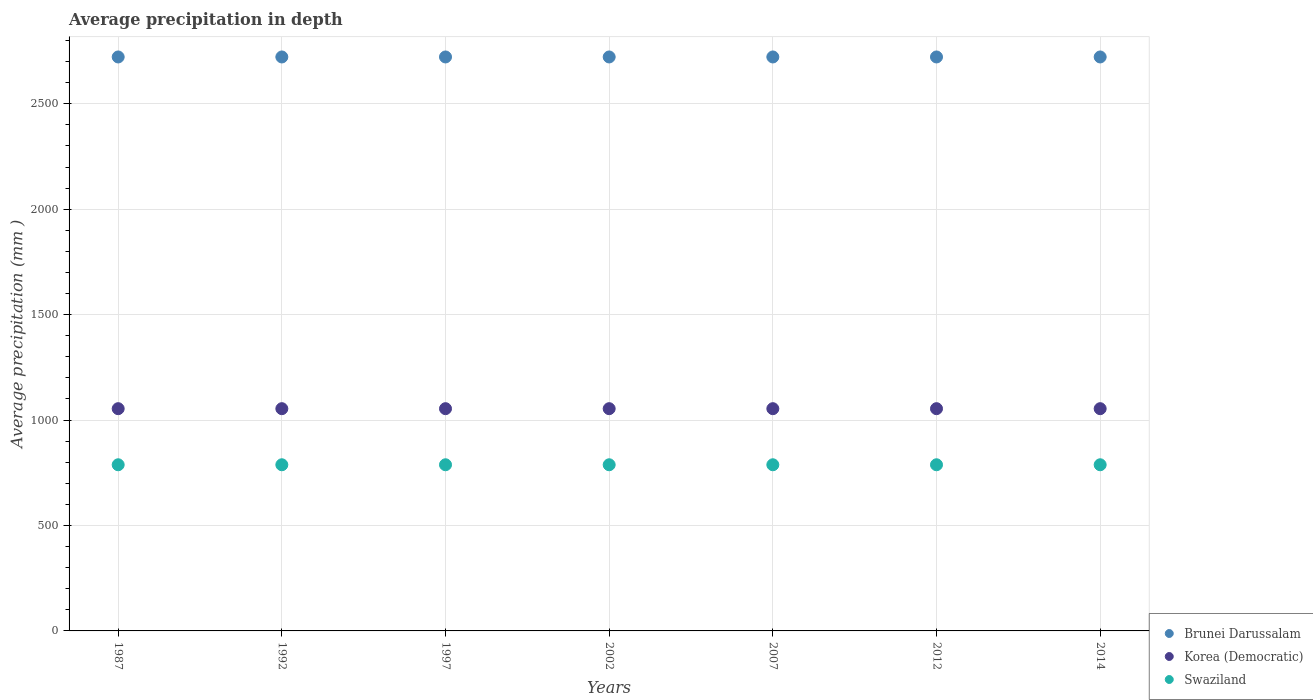Is the number of dotlines equal to the number of legend labels?
Your answer should be compact. Yes. What is the average precipitation in Korea (Democratic) in 1997?
Ensure brevity in your answer.  1054. Across all years, what is the maximum average precipitation in Korea (Democratic)?
Ensure brevity in your answer.  1054. Across all years, what is the minimum average precipitation in Korea (Democratic)?
Your answer should be very brief. 1054. In which year was the average precipitation in Brunei Darussalam minimum?
Your answer should be very brief. 1987. What is the total average precipitation in Swaziland in the graph?
Give a very brief answer. 5516. What is the difference between the average precipitation in Korea (Democratic) in 1992 and the average precipitation in Swaziland in 2014?
Your answer should be compact. 266. What is the average average precipitation in Brunei Darussalam per year?
Provide a succinct answer. 2722. In the year 2014, what is the difference between the average precipitation in Korea (Democratic) and average precipitation in Swaziland?
Offer a very short reply. 266. Is the average precipitation in Korea (Democratic) in 1992 less than that in 1997?
Offer a very short reply. No. In how many years, is the average precipitation in Brunei Darussalam greater than the average average precipitation in Brunei Darussalam taken over all years?
Provide a succinct answer. 0. Does the average precipitation in Swaziland monotonically increase over the years?
Provide a short and direct response. No. Are the values on the major ticks of Y-axis written in scientific E-notation?
Give a very brief answer. No. Does the graph contain any zero values?
Ensure brevity in your answer.  No. Does the graph contain grids?
Give a very brief answer. Yes. How are the legend labels stacked?
Your response must be concise. Vertical. What is the title of the graph?
Keep it short and to the point. Average precipitation in depth. Does "Malta" appear as one of the legend labels in the graph?
Your answer should be compact. No. What is the label or title of the Y-axis?
Your response must be concise. Average precipitation (mm ). What is the Average precipitation (mm ) of Brunei Darussalam in 1987?
Offer a very short reply. 2722. What is the Average precipitation (mm ) of Korea (Democratic) in 1987?
Your answer should be very brief. 1054. What is the Average precipitation (mm ) of Swaziland in 1987?
Make the answer very short. 788. What is the Average precipitation (mm ) of Brunei Darussalam in 1992?
Ensure brevity in your answer.  2722. What is the Average precipitation (mm ) in Korea (Democratic) in 1992?
Your answer should be very brief. 1054. What is the Average precipitation (mm ) in Swaziland in 1992?
Offer a very short reply. 788. What is the Average precipitation (mm ) of Brunei Darussalam in 1997?
Your answer should be compact. 2722. What is the Average precipitation (mm ) of Korea (Democratic) in 1997?
Your answer should be compact. 1054. What is the Average precipitation (mm ) in Swaziland in 1997?
Keep it short and to the point. 788. What is the Average precipitation (mm ) in Brunei Darussalam in 2002?
Give a very brief answer. 2722. What is the Average precipitation (mm ) of Korea (Democratic) in 2002?
Your response must be concise. 1054. What is the Average precipitation (mm ) of Swaziland in 2002?
Keep it short and to the point. 788. What is the Average precipitation (mm ) in Brunei Darussalam in 2007?
Keep it short and to the point. 2722. What is the Average precipitation (mm ) in Korea (Democratic) in 2007?
Ensure brevity in your answer.  1054. What is the Average precipitation (mm ) of Swaziland in 2007?
Offer a terse response. 788. What is the Average precipitation (mm ) of Brunei Darussalam in 2012?
Offer a terse response. 2722. What is the Average precipitation (mm ) in Korea (Democratic) in 2012?
Give a very brief answer. 1054. What is the Average precipitation (mm ) in Swaziland in 2012?
Your answer should be compact. 788. What is the Average precipitation (mm ) in Brunei Darussalam in 2014?
Ensure brevity in your answer.  2722. What is the Average precipitation (mm ) in Korea (Democratic) in 2014?
Offer a very short reply. 1054. What is the Average precipitation (mm ) of Swaziland in 2014?
Offer a very short reply. 788. Across all years, what is the maximum Average precipitation (mm ) of Brunei Darussalam?
Give a very brief answer. 2722. Across all years, what is the maximum Average precipitation (mm ) in Korea (Democratic)?
Provide a short and direct response. 1054. Across all years, what is the maximum Average precipitation (mm ) of Swaziland?
Offer a terse response. 788. Across all years, what is the minimum Average precipitation (mm ) in Brunei Darussalam?
Ensure brevity in your answer.  2722. Across all years, what is the minimum Average precipitation (mm ) of Korea (Democratic)?
Make the answer very short. 1054. Across all years, what is the minimum Average precipitation (mm ) in Swaziland?
Offer a terse response. 788. What is the total Average precipitation (mm ) in Brunei Darussalam in the graph?
Your answer should be compact. 1.91e+04. What is the total Average precipitation (mm ) of Korea (Democratic) in the graph?
Provide a short and direct response. 7378. What is the total Average precipitation (mm ) in Swaziland in the graph?
Your answer should be compact. 5516. What is the difference between the Average precipitation (mm ) of Swaziland in 1987 and that in 1992?
Keep it short and to the point. 0. What is the difference between the Average precipitation (mm ) in Brunei Darussalam in 1987 and that in 1997?
Give a very brief answer. 0. What is the difference between the Average precipitation (mm ) in Swaziland in 1987 and that in 1997?
Give a very brief answer. 0. What is the difference between the Average precipitation (mm ) of Brunei Darussalam in 1987 and that in 2007?
Ensure brevity in your answer.  0. What is the difference between the Average precipitation (mm ) in Korea (Democratic) in 1987 and that in 2007?
Your answer should be very brief. 0. What is the difference between the Average precipitation (mm ) of Swaziland in 1987 and that in 2007?
Make the answer very short. 0. What is the difference between the Average precipitation (mm ) of Korea (Democratic) in 1987 and that in 2012?
Provide a short and direct response. 0. What is the difference between the Average precipitation (mm ) in Korea (Democratic) in 1987 and that in 2014?
Offer a terse response. 0. What is the difference between the Average precipitation (mm ) in Korea (Democratic) in 1992 and that in 1997?
Ensure brevity in your answer.  0. What is the difference between the Average precipitation (mm ) of Swaziland in 1992 and that in 1997?
Your response must be concise. 0. What is the difference between the Average precipitation (mm ) in Brunei Darussalam in 1992 and that in 2007?
Offer a terse response. 0. What is the difference between the Average precipitation (mm ) of Swaziland in 1992 and that in 2007?
Your answer should be very brief. 0. What is the difference between the Average precipitation (mm ) of Brunei Darussalam in 1992 and that in 2012?
Your answer should be compact. 0. What is the difference between the Average precipitation (mm ) in Korea (Democratic) in 1992 and that in 2012?
Your answer should be very brief. 0. What is the difference between the Average precipitation (mm ) of Brunei Darussalam in 1992 and that in 2014?
Keep it short and to the point. 0. What is the difference between the Average precipitation (mm ) of Korea (Democratic) in 1992 and that in 2014?
Offer a terse response. 0. What is the difference between the Average precipitation (mm ) of Korea (Democratic) in 1997 and that in 2002?
Give a very brief answer. 0. What is the difference between the Average precipitation (mm ) in Brunei Darussalam in 1997 and that in 2007?
Ensure brevity in your answer.  0. What is the difference between the Average precipitation (mm ) in Brunei Darussalam in 1997 and that in 2012?
Give a very brief answer. 0. What is the difference between the Average precipitation (mm ) in Korea (Democratic) in 1997 and that in 2014?
Give a very brief answer. 0. What is the difference between the Average precipitation (mm ) in Swaziland in 1997 and that in 2014?
Provide a short and direct response. 0. What is the difference between the Average precipitation (mm ) in Korea (Democratic) in 2002 and that in 2007?
Your answer should be very brief. 0. What is the difference between the Average precipitation (mm ) in Swaziland in 2002 and that in 2007?
Your answer should be compact. 0. What is the difference between the Average precipitation (mm ) in Brunei Darussalam in 2002 and that in 2012?
Your answer should be compact. 0. What is the difference between the Average precipitation (mm ) in Swaziland in 2002 and that in 2012?
Ensure brevity in your answer.  0. What is the difference between the Average precipitation (mm ) of Brunei Darussalam in 2002 and that in 2014?
Make the answer very short. 0. What is the difference between the Average precipitation (mm ) of Korea (Democratic) in 2002 and that in 2014?
Make the answer very short. 0. What is the difference between the Average precipitation (mm ) of Brunei Darussalam in 2007 and that in 2012?
Make the answer very short. 0. What is the difference between the Average precipitation (mm ) in Swaziland in 2007 and that in 2012?
Your response must be concise. 0. What is the difference between the Average precipitation (mm ) in Korea (Democratic) in 2012 and that in 2014?
Provide a short and direct response. 0. What is the difference between the Average precipitation (mm ) of Brunei Darussalam in 1987 and the Average precipitation (mm ) of Korea (Democratic) in 1992?
Make the answer very short. 1668. What is the difference between the Average precipitation (mm ) in Brunei Darussalam in 1987 and the Average precipitation (mm ) in Swaziland in 1992?
Your answer should be compact. 1934. What is the difference between the Average precipitation (mm ) in Korea (Democratic) in 1987 and the Average precipitation (mm ) in Swaziland in 1992?
Offer a very short reply. 266. What is the difference between the Average precipitation (mm ) of Brunei Darussalam in 1987 and the Average precipitation (mm ) of Korea (Democratic) in 1997?
Your answer should be very brief. 1668. What is the difference between the Average precipitation (mm ) of Brunei Darussalam in 1987 and the Average precipitation (mm ) of Swaziland in 1997?
Offer a terse response. 1934. What is the difference between the Average precipitation (mm ) in Korea (Democratic) in 1987 and the Average precipitation (mm ) in Swaziland in 1997?
Provide a short and direct response. 266. What is the difference between the Average precipitation (mm ) of Brunei Darussalam in 1987 and the Average precipitation (mm ) of Korea (Democratic) in 2002?
Provide a succinct answer. 1668. What is the difference between the Average precipitation (mm ) of Brunei Darussalam in 1987 and the Average precipitation (mm ) of Swaziland in 2002?
Provide a short and direct response. 1934. What is the difference between the Average precipitation (mm ) of Korea (Democratic) in 1987 and the Average precipitation (mm ) of Swaziland in 2002?
Offer a terse response. 266. What is the difference between the Average precipitation (mm ) in Brunei Darussalam in 1987 and the Average precipitation (mm ) in Korea (Democratic) in 2007?
Provide a short and direct response. 1668. What is the difference between the Average precipitation (mm ) in Brunei Darussalam in 1987 and the Average precipitation (mm ) in Swaziland in 2007?
Provide a succinct answer. 1934. What is the difference between the Average precipitation (mm ) in Korea (Democratic) in 1987 and the Average precipitation (mm ) in Swaziland in 2007?
Make the answer very short. 266. What is the difference between the Average precipitation (mm ) of Brunei Darussalam in 1987 and the Average precipitation (mm ) of Korea (Democratic) in 2012?
Your response must be concise. 1668. What is the difference between the Average precipitation (mm ) in Brunei Darussalam in 1987 and the Average precipitation (mm ) in Swaziland in 2012?
Ensure brevity in your answer.  1934. What is the difference between the Average precipitation (mm ) in Korea (Democratic) in 1987 and the Average precipitation (mm ) in Swaziland in 2012?
Your answer should be very brief. 266. What is the difference between the Average precipitation (mm ) in Brunei Darussalam in 1987 and the Average precipitation (mm ) in Korea (Democratic) in 2014?
Offer a very short reply. 1668. What is the difference between the Average precipitation (mm ) in Brunei Darussalam in 1987 and the Average precipitation (mm ) in Swaziland in 2014?
Provide a short and direct response. 1934. What is the difference between the Average precipitation (mm ) of Korea (Democratic) in 1987 and the Average precipitation (mm ) of Swaziland in 2014?
Your response must be concise. 266. What is the difference between the Average precipitation (mm ) in Brunei Darussalam in 1992 and the Average precipitation (mm ) in Korea (Democratic) in 1997?
Your answer should be very brief. 1668. What is the difference between the Average precipitation (mm ) in Brunei Darussalam in 1992 and the Average precipitation (mm ) in Swaziland in 1997?
Your response must be concise. 1934. What is the difference between the Average precipitation (mm ) of Korea (Democratic) in 1992 and the Average precipitation (mm ) of Swaziland in 1997?
Keep it short and to the point. 266. What is the difference between the Average precipitation (mm ) in Brunei Darussalam in 1992 and the Average precipitation (mm ) in Korea (Democratic) in 2002?
Give a very brief answer. 1668. What is the difference between the Average precipitation (mm ) in Brunei Darussalam in 1992 and the Average precipitation (mm ) in Swaziland in 2002?
Give a very brief answer. 1934. What is the difference between the Average precipitation (mm ) in Korea (Democratic) in 1992 and the Average precipitation (mm ) in Swaziland in 2002?
Provide a succinct answer. 266. What is the difference between the Average precipitation (mm ) of Brunei Darussalam in 1992 and the Average precipitation (mm ) of Korea (Democratic) in 2007?
Provide a succinct answer. 1668. What is the difference between the Average precipitation (mm ) in Brunei Darussalam in 1992 and the Average precipitation (mm ) in Swaziland in 2007?
Provide a succinct answer. 1934. What is the difference between the Average precipitation (mm ) of Korea (Democratic) in 1992 and the Average precipitation (mm ) of Swaziland in 2007?
Your answer should be very brief. 266. What is the difference between the Average precipitation (mm ) of Brunei Darussalam in 1992 and the Average precipitation (mm ) of Korea (Democratic) in 2012?
Give a very brief answer. 1668. What is the difference between the Average precipitation (mm ) of Brunei Darussalam in 1992 and the Average precipitation (mm ) of Swaziland in 2012?
Ensure brevity in your answer.  1934. What is the difference between the Average precipitation (mm ) in Korea (Democratic) in 1992 and the Average precipitation (mm ) in Swaziland in 2012?
Ensure brevity in your answer.  266. What is the difference between the Average precipitation (mm ) of Brunei Darussalam in 1992 and the Average precipitation (mm ) of Korea (Democratic) in 2014?
Give a very brief answer. 1668. What is the difference between the Average precipitation (mm ) of Brunei Darussalam in 1992 and the Average precipitation (mm ) of Swaziland in 2014?
Offer a very short reply. 1934. What is the difference between the Average precipitation (mm ) of Korea (Democratic) in 1992 and the Average precipitation (mm ) of Swaziland in 2014?
Offer a terse response. 266. What is the difference between the Average precipitation (mm ) of Brunei Darussalam in 1997 and the Average precipitation (mm ) of Korea (Democratic) in 2002?
Offer a terse response. 1668. What is the difference between the Average precipitation (mm ) in Brunei Darussalam in 1997 and the Average precipitation (mm ) in Swaziland in 2002?
Ensure brevity in your answer.  1934. What is the difference between the Average precipitation (mm ) in Korea (Democratic) in 1997 and the Average precipitation (mm ) in Swaziland in 2002?
Ensure brevity in your answer.  266. What is the difference between the Average precipitation (mm ) in Brunei Darussalam in 1997 and the Average precipitation (mm ) in Korea (Democratic) in 2007?
Offer a terse response. 1668. What is the difference between the Average precipitation (mm ) of Brunei Darussalam in 1997 and the Average precipitation (mm ) of Swaziland in 2007?
Offer a very short reply. 1934. What is the difference between the Average precipitation (mm ) of Korea (Democratic) in 1997 and the Average precipitation (mm ) of Swaziland in 2007?
Make the answer very short. 266. What is the difference between the Average precipitation (mm ) of Brunei Darussalam in 1997 and the Average precipitation (mm ) of Korea (Democratic) in 2012?
Make the answer very short. 1668. What is the difference between the Average precipitation (mm ) in Brunei Darussalam in 1997 and the Average precipitation (mm ) in Swaziland in 2012?
Offer a very short reply. 1934. What is the difference between the Average precipitation (mm ) in Korea (Democratic) in 1997 and the Average precipitation (mm ) in Swaziland in 2012?
Your answer should be compact. 266. What is the difference between the Average precipitation (mm ) in Brunei Darussalam in 1997 and the Average precipitation (mm ) in Korea (Democratic) in 2014?
Ensure brevity in your answer.  1668. What is the difference between the Average precipitation (mm ) of Brunei Darussalam in 1997 and the Average precipitation (mm ) of Swaziland in 2014?
Make the answer very short. 1934. What is the difference between the Average precipitation (mm ) of Korea (Democratic) in 1997 and the Average precipitation (mm ) of Swaziland in 2014?
Provide a succinct answer. 266. What is the difference between the Average precipitation (mm ) of Brunei Darussalam in 2002 and the Average precipitation (mm ) of Korea (Democratic) in 2007?
Give a very brief answer. 1668. What is the difference between the Average precipitation (mm ) in Brunei Darussalam in 2002 and the Average precipitation (mm ) in Swaziland in 2007?
Offer a terse response. 1934. What is the difference between the Average precipitation (mm ) of Korea (Democratic) in 2002 and the Average precipitation (mm ) of Swaziland in 2007?
Make the answer very short. 266. What is the difference between the Average precipitation (mm ) of Brunei Darussalam in 2002 and the Average precipitation (mm ) of Korea (Democratic) in 2012?
Your answer should be compact. 1668. What is the difference between the Average precipitation (mm ) of Brunei Darussalam in 2002 and the Average precipitation (mm ) of Swaziland in 2012?
Keep it short and to the point. 1934. What is the difference between the Average precipitation (mm ) in Korea (Democratic) in 2002 and the Average precipitation (mm ) in Swaziland in 2012?
Your answer should be compact. 266. What is the difference between the Average precipitation (mm ) of Brunei Darussalam in 2002 and the Average precipitation (mm ) of Korea (Democratic) in 2014?
Your answer should be very brief. 1668. What is the difference between the Average precipitation (mm ) of Brunei Darussalam in 2002 and the Average precipitation (mm ) of Swaziland in 2014?
Keep it short and to the point. 1934. What is the difference between the Average precipitation (mm ) of Korea (Democratic) in 2002 and the Average precipitation (mm ) of Swaziland in 2014?
Offer a very short reply. 266. What is the difference between the Average precipitation (mm ) of Brunei Darussalam in 2007 and the Average precipitation (mm ) of Korea (Democratic) in 2012?
Keep it short and to the point. 1668. What is the difference between the Average precipitation (mm ) of Brunei Darussalam in 2007 and the Average precipitation (mm ) of Swaziland in 2012?
Offer a terse response. 1934. What is the difference between the Average precipitation (mm ) in Korea (Democratic) in 2007 and the Average precipitation (mm ) in Swaziland in 2012?
Your response must be concise. 266. What is the difference between the Average precipitation (mm ) of Brunei Darussalam in 2007 and the Average precipitation (mm ) of Korea (Democratic) in 2014?
Offer a terse response. 1668. What is the difference between the Average precipitation (mm ) in Brunei Darussalam in 2007 and the Average precipitation (mm ) in Swaziland in 2014?
Provide a succinct answer. 1934. What is the difference between the Average precipitation (mm ) in Korea (Democratic) in 2007 and the Average precipitation (mm ) in Swaziland in 2014?
Provide a short and direct response. 266. What is the difference between the Average precipitation (mm ) in Brunei Darussalam in 2012 and the Average precipitation (mm ) in Korea (Democratic) in 2014?
Make the answer very short. 1668. What is the difference between the Average precipitation (mm ) of Brunei Darussalam in 2012 and the Average precipitation (mm ) of Swaziland in 2014?
Provide a short and direct response. 1934. What is the difference between the Average precipitation (mm ) in Korea (Democratic) in 2012 and the Average precipitation (mm ) in Swaziland in 2014?
Provide a short and direct response. 266. What is the average Average precipitation (mm ) of Brunei Darussalam per year?
Your answer should be very brief. 2722. What is the average Average precipitation (mm ) in Korea (Democratic) per year?
Your response must be concise. 1054. What is the average Average precipitation (mm ) of Swaziland per year?
Provide a short and direct response. 788. In the year 1987, what is the difference between the Average precipitation (mm ) in Brunei Darussalam and Average precipitation (mm ) in Korea (Democratic)?
Your answer should be very brief. 1668. In the year 1987, what is the difference between the Average precipitation (mm ) of Brunei Darussalam and Average precipitation (mm ) of Swaziland?
Offer a very short reply. 1934. In the year 1987, what is the difference between the Average precipitation (mm ) in Korea (Democratic) and Average precipitation (mm ) in Swaziland?
Make the answer very short. 266. In the year 1992, what is the difference between the Average precipitation (mm ) of Brunei Darussalam and Average precipitation (mm ) of Korea (Democratic)?
Your answer should be compact. 1668. In the year 1992, what is the difference between the Average precipitation (mm ) in Brunei Darussalam and Average precipitation (mm ) in Swaziland?
Provide a succinct answer. 1934. In the year 1992, what is the difference between the Average precipitation (mm ) of Korea (Democratic) and Average precipitation (mm ) of Swaziland?
Ensure brevity in your answer.  266. In the year 1997, what is the difference between the Average precipitation (mm ) of Brunei Darussalam and Average precipitation (mm ) of Korea (Democratic)?
Make the answer very short. 1668. In the year 1997, what is the difference between the Average precipitation (mm ) of Brunei Darussalam and Average precipitation (mm ) of Swaziland?
Your response must be concise. 1934. In the year 1997, what is the difference between the Average precipitation (mm ) in Korea (Democratic) and Average precipitation (mm ) in Swaziland?
Ensure brevity in your answer.  266. In the year 2002, what is the difference between the Average precipitation (mm ) in Brunei Darussalam and Average precipitation (mm ) in Korea (Democratic)?
Provide a short and direct response. 1668. In the year 2002, what is the difference between the Average precipitation (mm ) in Brunei Darussalam and Average precipitation (mm ) in Swaziland?
Give a very brief answer. 1934. In the year 2002, what is the difference between the Average precipitation (mm ) in Korea (Democratic) and Average precipitation (mm ) in Swaziland?
Your response must be concise. 266. In the year 2007, what is the difference between the Average precipitation (mm ) in Brunei Darussalam and Average precipitation (mm ) in Korea (Democratic)?
Offer a very short reply. 1668. In the year 2007, what is the difference between the Average precipitation (mm ) of Brunei Darussalam and Average precipitation (mm ) of Swaziland?
Offer a very short reply. 1934. In the year 2007, what is the difference between the Average precipitation (mm ) of Korea (Democratic) and Average precipitation (mm ) of Swaziland?
Offer a terse response. 266. In the year 2012, what is the difference between the Average precipitation (mm ) in Brunei Darussalam and Average precipitation (mm ) in Korea (Democratic)?
Provide a short and direct response. 1668. In the year 2012, what is the difference between the Average precipitation (mm ) in Brunei Darussalam and Average precipitation (mm ) in Swaziland?
Offer a terse response. 1934. In the year 2012, what is the difference between the Average precipitation (mm ) in Korea (Democratic) and Average precipitation (mm ) in Swaziland?
Ensure brevity in your answer.  266. In the year 2014, what is the difference between the Average precipitation (mm ) in Brunei Darussalam and Average precipitation (mm ) in Korea (Democratic)?
Offer a very short reply. 1668. In the year 2014, what is the difference between the Average precipitation (mm ) of Brunei Darussalam and Average precipitation (mm ) of Swaziland?
Your response must be concise. 1934. In the year 2014, what is the difference between the Average precipitation (mm ) of Korea (Democratic) and Average precipitation (mm ) of Swaziland?
Provide a succinct answer. 266. What is the ratio of the Average precipitation (mm ) in Swaziland in 1987 to that in 1992?
Your response must be concise. 1. What is the ratio of the Average precipitation (mm ) in Brunei Darussalam in 1987 to that in 1997?
Provide a succinct answer. 1. What is the ratio of the Average precipitation (mm ) of Korea (Democratic) in 1987 to that in 1997?
Keep it short and to the point. 1. What is the ratio of the Average precipitation (mm ) in Swaziland in 1987 to that in 1997?
Your answer should be very brief. 1. What is the ratio of the Average precipitation (mm ) in Korea (Democratic) in 1987 to that in 2002?
Make the answer very short. 1. What is the ratio of the Average precipitation (mm ) in Swaziland in 1987 to that in 2002?
Offer a very short reply. 1. What is the ratio of the Average precipitation (mm ) of Brunei Darussalam in 1987 to that in 2007?
Offer a terse response. 1. What is the ratio of the Average precipitation (mm ) in Swaziland in 1987 to that in 2012?
Provide a short and direct response. 1. What is the ratio of the Average precipitation (mm ) of Korea (Democratic) in 1987 to that in 2014?
Give a very brief answer. 1. What is the ratio of the Average precipitation (mm ) of Swaziland in 1992 to that in 1997?
Your answer should be compact. 1. What is the ratio of the Average precipitation (mm ) of Brunei Darussalam in 1992 to that in 2002?
Provide a short and direct response. 1. What is the ratio of the Average precipitation (mm ) in Swaziland in 1992 to that in 2002?
Provide a short and direct response. 1. What is the ratio of the Average precipitation (mm ) of Korea (Democratic) in 1992 to that in 2007?
Make the answer very short. 1. What is the ratio of the Average precipitation (mm ) of Brunei Darussalam in 1992 to that in 2012?
Offer a very short reply. 1. What is the ratio of the Average precipitation (mm ) of Korea (Democratic) in 1992 to that in 2012?
Give a very brief answer. 1. What is the ratio of the Average precipitation (mm ) of Swaziland in 1992 to that in 2012?
Ensure brevity in your answer.  1. What is the ratio of the Average precipitation (mm ) in Brunei Darussalam in 1992 to that in 2014?
Offer a terse response. 1. What is the ratio of the Average precipitation (mm ) in Swaziland in 1992 to that in 2014?
Provide a short and direct response. 1. What is the ratio of the Average precipitation (mm ) in Korea (Democratic) in 1997 to that in 2002?
Offer a very short reply. 1. What is the ratio of the Average precipitation (mm ) in Swaziland in 1997 to that in 2002?
Provide a succinct answer. 1. What is the ratio of the Average precipitation (mm ) in Brunei Darussalam in 1997 to that in 2007?
Provide a succinct answer. 1. What is the ratio of the Average precipitation (mm ) in Korea (Democratic) in 1997 to that in 2007?
Your answer should be compact. 1. What is the ratio of the Average precipitation (mm ) of Brunei Darussalam in 1997 to that in 2012?
Offer a terse response. 1. What is the ratio of the Average precipitation (mm ) in Swaziland in 1997 to that in 2012?
Give a very brief answer. 1. What is the ratio of the Average precipitation (mm ) in Korea (Democratic) in 1997 to that in 2014?
Make the answer very short. 1. What is the ratio of the Average precipitation (mm ) of Brunei Darussalam in 2002 to that in 2007?
Make the answer very short. 1. What is the ratio of the Average precipitation (mm ) in Swaziland in 2002 to that in 2007?
Your answer should be compact. 1. What is the ratio of the Average precipitation (mm ) in Brunei Darussalam in 2002 to that in 2012?
Keep it short and to the point. 1. What is the ratio of the Average precipitation (mm ) in Korea (Democratic) in 2002 to that in 2014?
Your answer should be compact. 1. What is the ratio of the Average precipitation (mm ) in Swaziland in 2002 to that in 2014?
Give a very brief answer. 1. What is the ratio of the Average precipitation (mm ) of Brunei Darussalam in 2007 to that in 2012?
Keep it short and to the point. 1. What is the ratio of the Average precipitation (mm ) of Swaziland in 2007 to that in 2012?
Make the answer very short. 1. What is the ratio of the Average precipitation (mm ) in Korea (Democratic) in 2007 to that in 2014?
Give a very brief answer. 1. What is the ratio of the Average precipitation (mm ) in Swaziland in 2007 to that in 2014?
Provide a short and direct response. 1. What is the ratio of the Average precipitation (mm ) in Brunei Darussalam in 2012 to that in 2014?
Give a very brief answer. 1. What is the ratio of the Average precipitation (mm ) of Swaziland in 2012 to that in 2014?
Your response must be concise. 1. What is the difference between the highest and the second highest Average precipitation (mm ) of Brunei Darussalam?
Your answer should be very brief. 0. What is the difference between the highest and the second highest Average precipitation (mm ) in Korea (Democratic)?
Offer a terse response. 0. What is the difference between the highest and the second highest Average precipitation (mm ) of Swaziland?
Keep it short and to the point. 0. What is the difference between the highest and the lowest Average precipitation (mm ) of Korea (Democratic)?
Your answer should be compact. 0. What is the difference between the highest and the lowest Average precipitation (mm ) in Swaziland?
Make the answer very short. 0. 